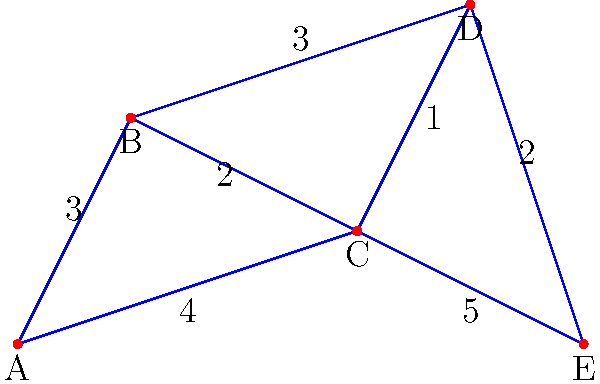As a veteran journalist covering infrastructure and transportation, you're investigating the most efficient route between cities for a new high-speed rail project. Given the map of cities and their connections, what is the shortest path from city A to city E, and what is its total distance? To find the shortest path from city A to city E, we'll use Dijkstra's algorithm, which is commonly used in graph theory for finding the shortest paths between nodes in a graph.

Step 1: Initialize distances
- Set distance to A as 0 (starting point)
- Set distances to all other cities as infinity

Step 2: Visit unvisited vertices
1. Start at A (distance 0)
   - To B: 0 + 3 = 3
   - To C: 0 + 4 = 4
2. Visit B (shortest unvisited, distance 3)
   - To C: min(4, 3 + 2) = 4 (no change)
   - To D: 3 + 3 = 6
3. Visit C (shortest unvisited, distance 4)
   - To D: min(6, 4 + 1) = 5
   - To E: 4 + 5 = 9
4. Visit D (shortest unvisited, distance 5)
   - To E: min(9, 5 + 2) = 7

Step 3: Backtrack to find the path
- E came from D (7)
- D came from C (5)
- C came from A (4)

Therefore, the shortest path is A -> C -> D -> E, with a total distance of 7.
Answer: A -> C -> D -> E, distance 7 